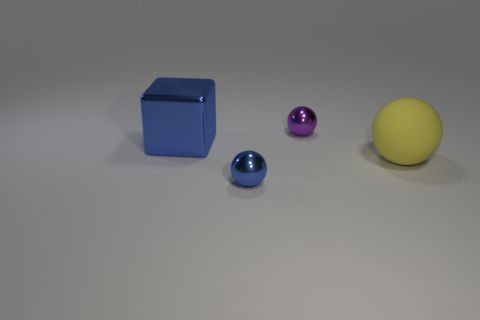Is there any other thing that is the same shape as the large metal object?
Provide a succinct answer. No. There is a object to the right of the purple sphere; is it the same shape as the purple object?
Provide a succinct answer. Yes. The metallic cube is what color?
Keep it short and to the point. Blue. The matte thing that is the same shape as the tiny blue metallic object is what color?
Ensure brevity in your answer.  Yellow. How many blue objects have the same shape as the yellow object?
Keep it short and to the point. 1. How many things are big cubes or shiny things that are to the left of the small blue ball?
Your answer should be compact. 1. Is the color of the matte thing the same as the metal sphere behind the blue metallic block?
Offer a terse response. No. There is a object that is both in front of the blue metal block and to the left of the yellow rubber sphere; what is its size?
Offer a very short reply. Small. There is a yellow rubber thing; are there any blue shiny cubes to the right of it?
Ensure brevity in your answer.  No. There is a blue thing in front of the big blue metallic block; are there any small shiny objects on the right side of it?
Keep it short and to the point. Yes. 